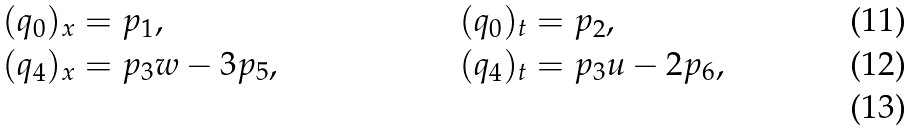<formula> <loc_0><loc_0><loc_500><loc_500>( q _ { 0 } ) _ { x } & = p _ { 1 } , & & ( q _ { 0 } ) _ { t } = p _ { 2 } , \\ ( q _ { 4 } ) _ { x } & = p _ { 3 } w - 3 p _ { 5 } , & & ( q _ { 4 } ) _ { t } = p _ { 3 } u - 2 p _ { 6 } , \\</formula> 